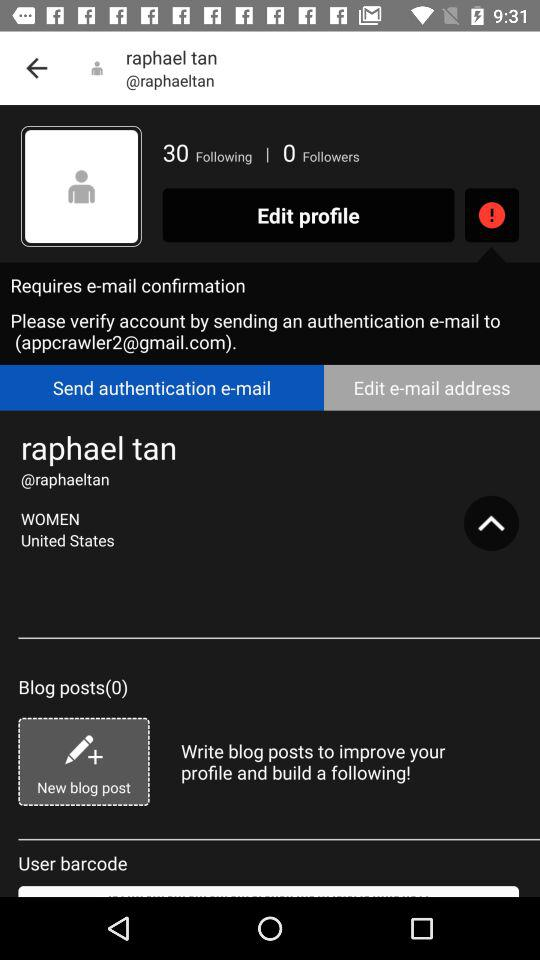What is the name of the country? The name of the country is the United States. 